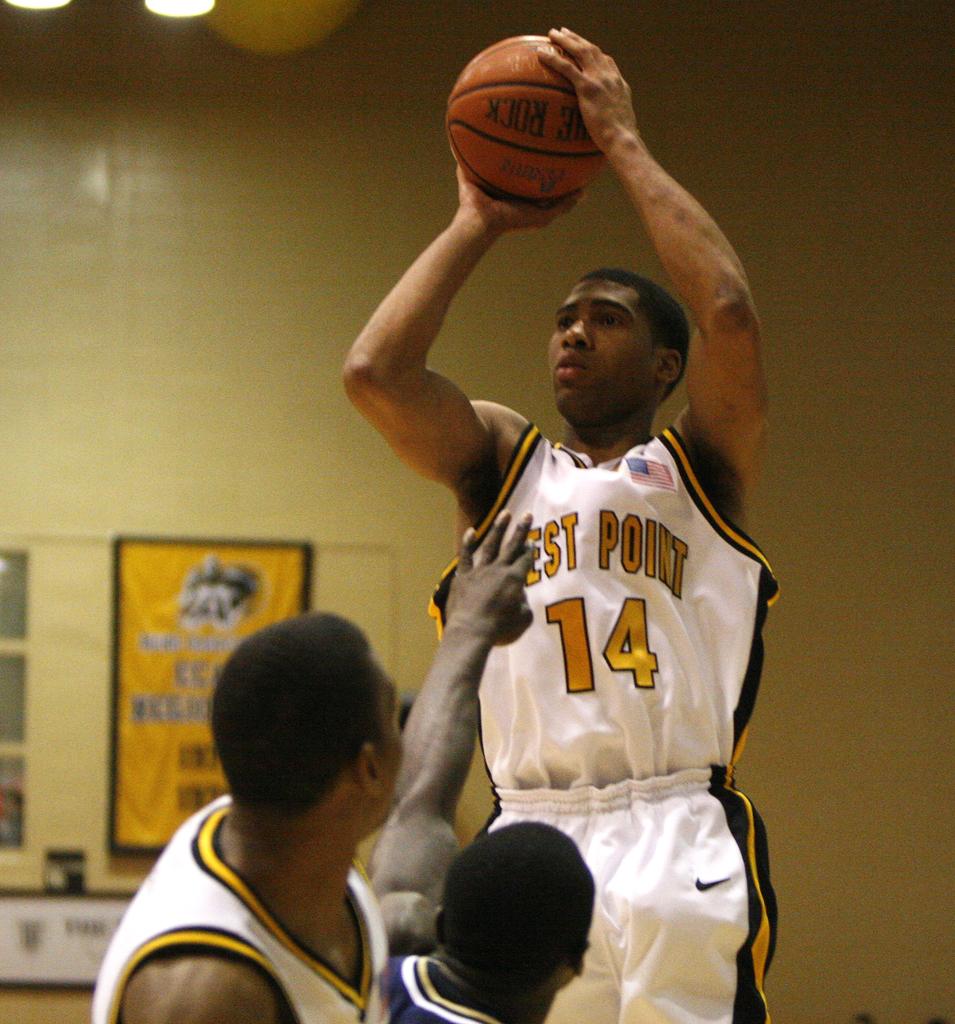What number is on the player who is jumping with the ball?
Provide a succinct answer. 14. What team does the man play for?
Your answer should be very brief. West point. 